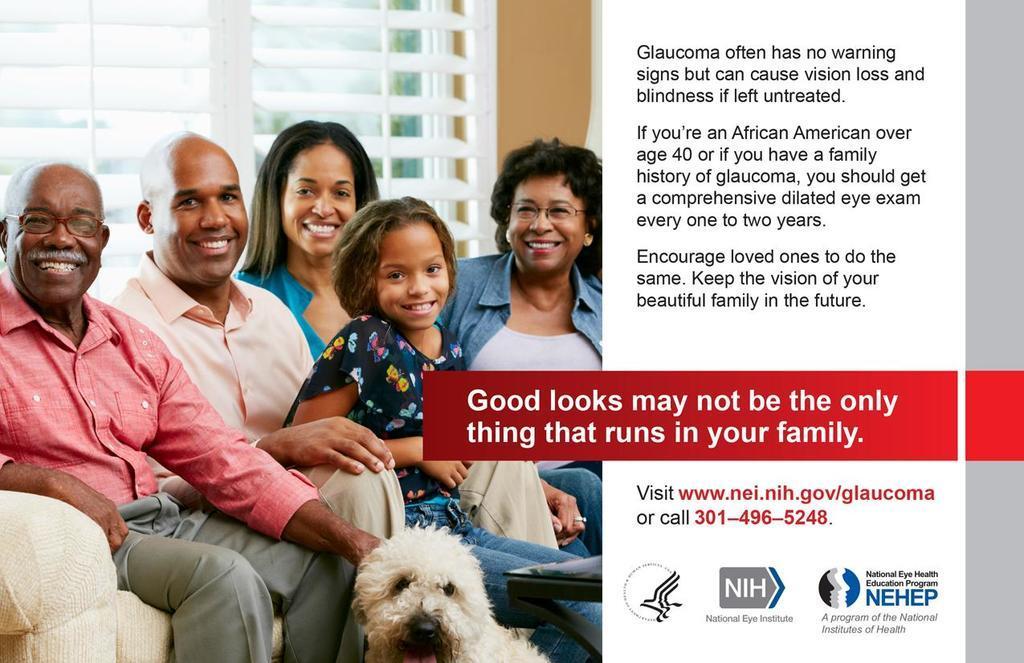How would you summarize this image in a sentence or two? This is a poster,on the left there are few people sitting on the sofa and on left at the person leg there is a dog. On the right we can see text written from the top to bottom. 